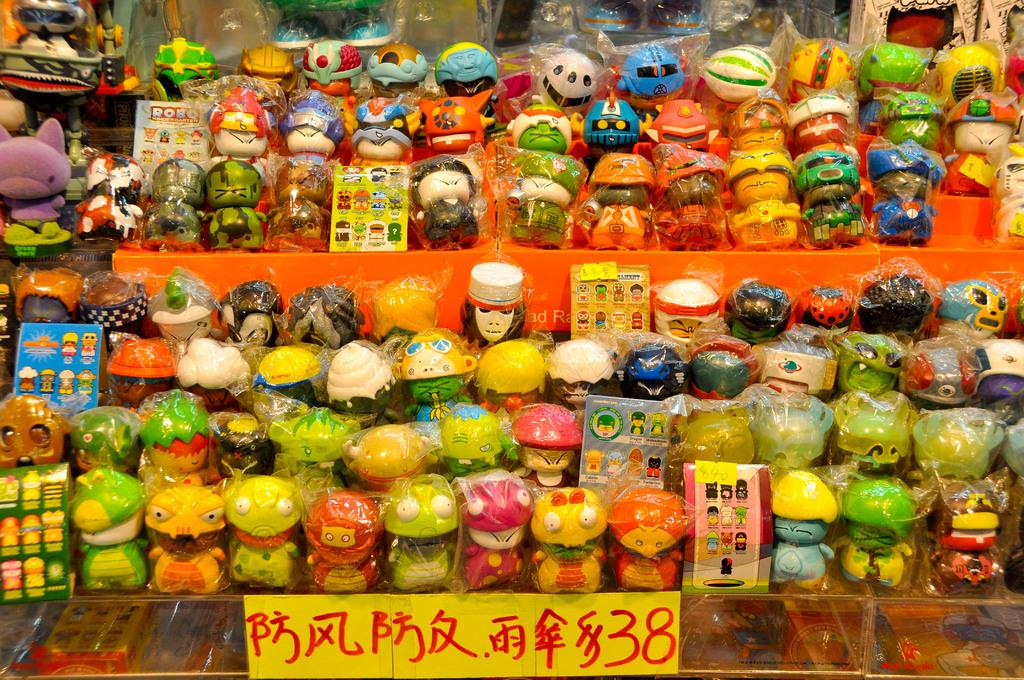<image>
Offer a succinct explanation of the picture presented. display of robq figures behind a sign with asian writing and 38 on it 